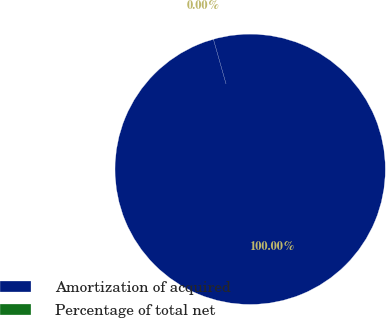<chart> <loc_0><loc_0><loc_500><loc_500><pie_chart><fcel>Amortization of acquired<fcel>Percentage of total net<nl><fcel>100.0%<fcel>0.0%<nl></chart> 